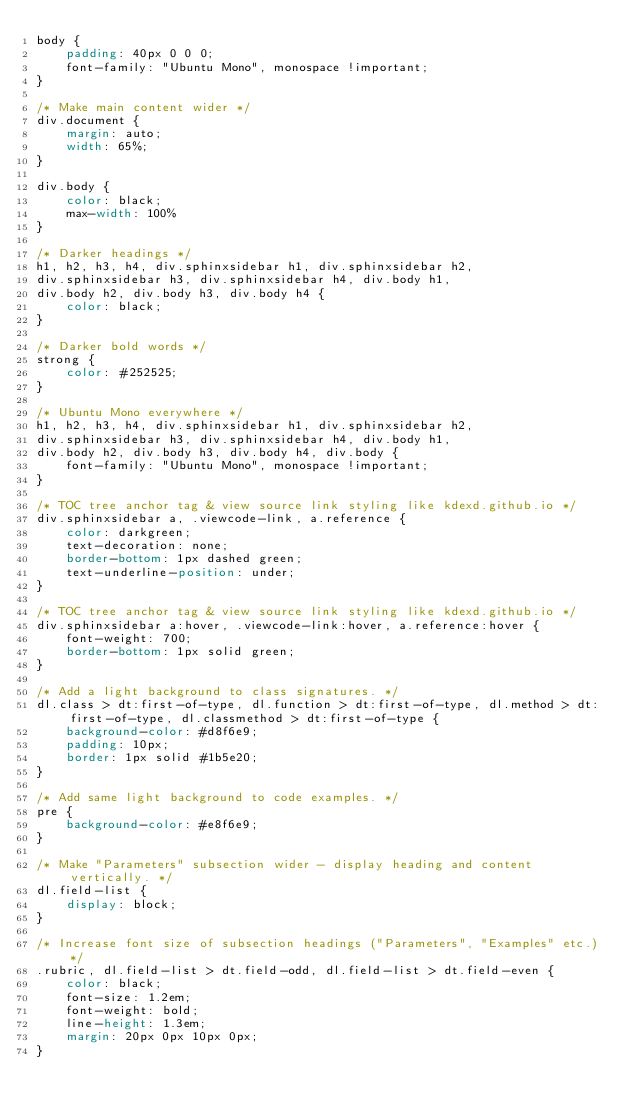<code> <loc_0><loc_0><loc_500><loc_500><_CSS_>body {
    padding: 40px 0 0 0;
    font-family: "Ubuntu Mono", monospace !important;
}

/* Make main content wider */
div.document {
    margin: auto;
    width: 65%;
}

div.body {
    color: black;
    max-width: 100%
}

/* Darker headings */
h1, h2, h3, h4, div.sphinxsidebar h1, div.sphinxsidebar h2,
div.sphinxsidebar h3, div.sphinxsidebar h4, div.body h1,
div.body h2, div.body h3, div.body h4 {
    color: black;
}

/* Darker bold words */
strong {
    color: #252525;
}

/* Ubuntu Mono everywhere */
h1, h2, h3, h4, div.sphinxsidebar h1, div.sphinxsidebar h2,
div.sphinxsidebar h3, div.sphinxsidebar h4, div.body h1,
div.body h2, div.body h3, div.body h4, div.body {
    font-family: "Ubuntu Mono", monospace !important;
}

/* TOC tree anchor tag & view source link styling like kdexd.github.io */
div.sphinxsidebar a, .viewcode-link, a.reference {
    color: darkgreen;
    text-decoration: none;
    border-bottom: 1px dashed green;
    text-underline-position: under;
}

/* TOC tree anchor tag & view source link styling like kdexd.github.io */
div.sphinxsidebar a:hover, .viewcode-link:hover, a.reference:hover {
    font-weight: 700;
    border-bottom: 1px solid green;
}

/* Add a light background to class signatures. */
dl.class > dt:first-of-type, dl.function > dt:first-of-type, dl.method > dt:first-of-type, dl.classmethod > dt:first-of-type {
    background-color: #d8f6e9;
    padding: 10px;
    border: 1px solid #1b5e20;
}

/* Add same light background to code examples. */
pre {
    background-color: #e8f6e9;
}

/* Make "Parameters" subsection wider - display heading and content vertically. */
dl.field-list {
    display: block;
}

/* Increase font size of subsection headings ("Parameters", "Examples" etc.) */
.rubric, dl.field-list > dt.field-odd, dl.field-list > dt.field-even {
    color: black;
    font-size: 1.2em;
    font-weight: bold;
    line-height: 1.3em;
    margin: 20px 0px 10px 0px;
}
</code> 